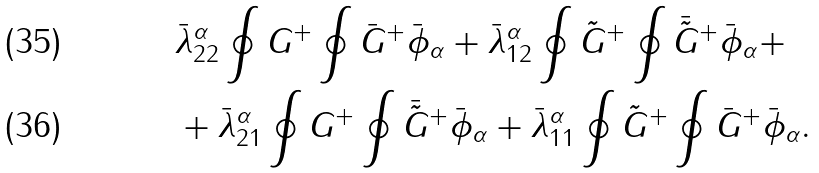<formula> <loc_0><loc_0><loc_500><loc_500>& \bar { \lambda } ^ { \alpha } _ { 2 2 } \oint G ^ { + } \oint \bar { G } ^ { + } \bar { \phi } _ { \alpha } + \bar { \lambda } ^ { \alpha } _ { 1 2 } \oint \tilde { G } ^ { + } \oint \bar { \tilde { G } } ^ { + } \bar { \phi } _ { \alpha } + \\ & + \bar { \lambda } ^ { \alpha } _ { 2 1 } \oint G ^ { + } \oint \bar { \tilde { G } } ^ { + } \bar { \phi } _ { \alpha } + \bar { \lambda } ^ { \alpha } _ { 1 1 } \oint \tilde { G } ^ { + } \oint \bar { G } ^ { + } \bar { \phi } _ { \alpha } .</formula> 